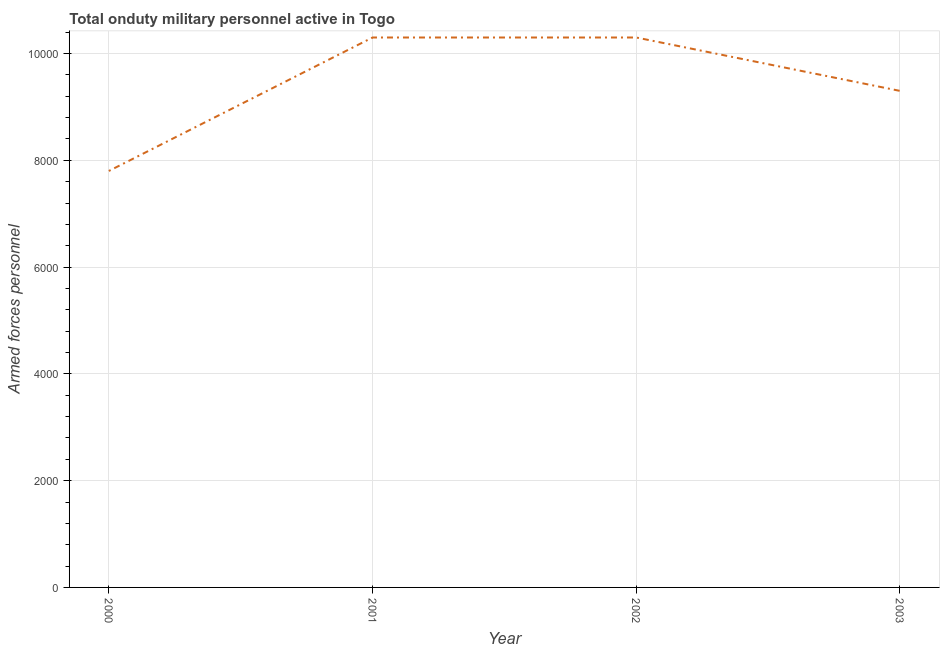What is the number of armed forces personnel in 2000?
Provide a short and direct response. 7800. Across all years, what is the maximum number of armed forces personnel?
Give a very brief answer. 1.03e+04. Across all years, what is the minimum number of armed forces personnel?
Provide a short and direct response. 7800. In which year was the number of armed forces personnel minimum?
Keep it short and to the point. 2000. What is the sum of the number of armed forces personnel?
Ensure brevity in your answer.  3.77e+04. What is the difference between the number of armed forces personnel in 2000 and 2002?
Give a very brief answer. -2500. What is the average number of armed forces personnel per year?
Your answer should be very brief. 9425. What is the median number of armed forces personnel?
Provide a short and direct response. 9800. Do a majority of the years between 2001 and 2003 (inclusive) have number of armed forces personnel greater than 7200 ?
Make the answer very short. Yes. What is the ratio of the number of armed forces personnel in 2002 to that in 2003?
Give a very brief answer. 1.11. Is the number of armed forces personnel in 2001 less than that in 2003?
Give a very brief answer. No. What is the difference between the highest and the second highest number of armed forces personnel?
Keep it short and to the point. 0. Is the sum of the number of armed forces personnel in 2001 and 2002 greater than the maximum number of armed forces personnel across all years?
Your response must be concise. Yes. What is the difference between the highest and the lowest number of armed forces personnel?
Provide a succinct answer. 2500. In how many years, is the number of armed forces personnel greater than the average number of armed forces personnel taken over all years?
Provide a short and direct response. 2. How many lines are there?
Make the answer very short. 1. How many years are there in the graph?
Make the answer very short. 4. Are the values on the major ticks of Y-axis written in scientific E-notation?
Ensure brevity in your answer.  No. Does the graph contain any zero values?
Make the answer very short. No. Does the graph contain grids?
Keep it short and to the point. Yes. What is the title of the graph?
Keep it short and to the point. Total onduty military personnel active in Togo. What is the label or title of the Y-axis?
Offer a terse response. Armed forces personnel. What is the Armed forces personnel of 2000?
Your answer should be compact. 7800. What is the Armed forces personnel of 2001?
Offer a very short reply. 1.03e+04. What is the Armed forces personnel of 2002?
Your response must be concise. 1.03e+04. What is the Armed forces personnel in 2003?
Make the answer very short. 9300. What is the difference between the Armed forces personnel in 2000 and 2001?
Your response must be concise. -2500. What is the difference between the Armed forces personnel in 2000 and 2002?
Your answer should be very brief. -2500. What is the difference between the Armed forces personnel in 2000 and 2003?
Your response must be concise. -1500. What is the difference between the Armed forces personnel in 2001 and 2002?
Provide a succinct answer. 0. What is the difference between the Armed forces personnel in 2001 and 2003?
Make the answer very short. 1000. What is the ratio of the Armed forces personnel in 2000 to that in 2001?
Your answer should be compact. 0.76. What is the ratio of the Armed forces personnel in 2000 to that in 2002?
Provide a succinct answer. 0.76. What is the ratio of the Armed forces personnel in 2000 to that in 2003?
Give a very brief answer. 0.84. What is the ratio of the Armed forces personnel in 2001 to that in 2003?
Provide a short and direct response. 1.11. What is the ratio of the Armed forces personnel in 2002 to that in 2003?
Keep it short and to the point. 1.11. 